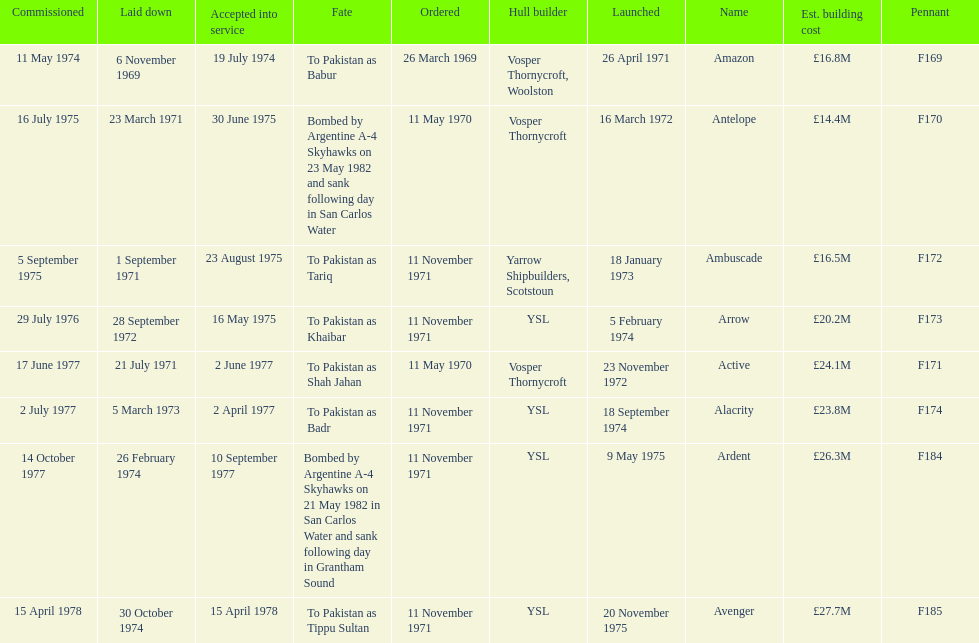Tell me the number of ships that went to pakistan. 6. 